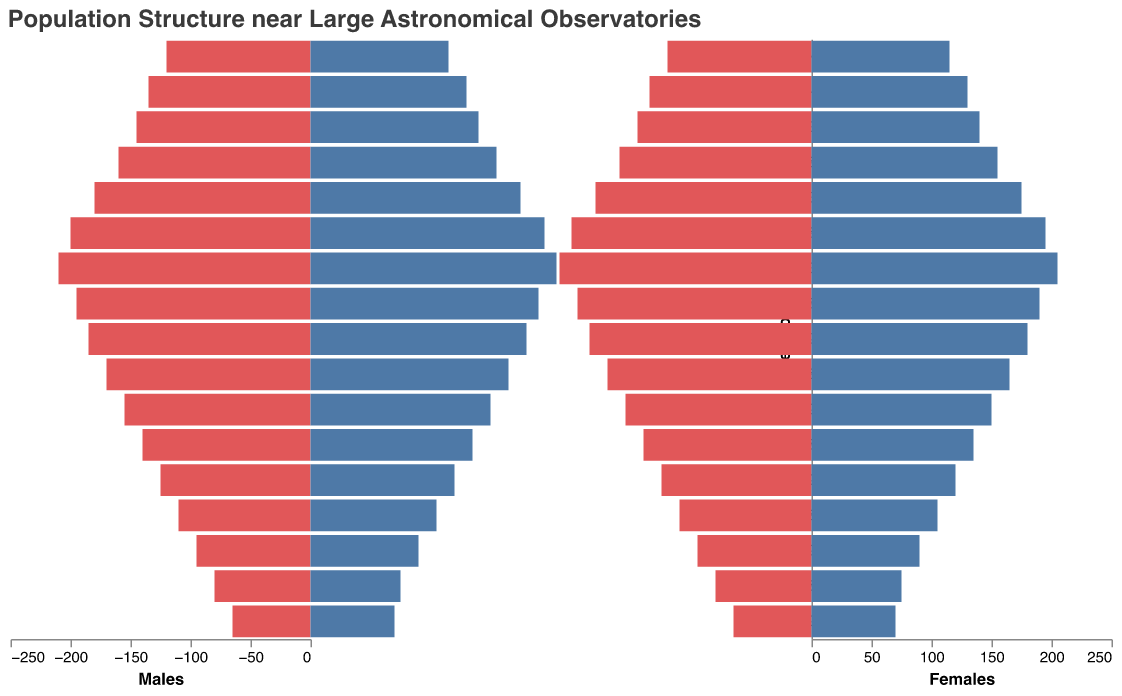What is the title of the figure? The title can be found at the top of the figure. It states what the figure is about.
Answer: Population Structure near Large Astronomical Observatories What is the age group with the highest population for females? Observe the right side of the population pyramid and look for the bar representing the widest segment, which corresponds to females aged 30-34.
Answer: 30-34 How does the population of males aged 25-29 compare to females of the same age group? Compare the lengths of the bars for males and females in the 25-29 age group. The bar for males is slightly longer than for females.
Answer: Males have a higher population What trends can be observed in the population as the age groups increase from 0-4 to 80+ for both genders? Observe the overall shape of the pyramid. Generally, the bars become shorter as the age groups increase, indicating a decreasing population with age.
Answer: Population decreases with age What is the total population for the 70-74 age group? Add the population numbers for males and females in the 70-74 age group: 95 (males) + 90 (females) = 185.
Answer: 185 Which age group has a male population closest to 150? Look for the bar representing males in an age group near the value of 150. The bar for the age group 50-54 is closest with a population of 155.
Answer: 50-54 At what age group is the population of females exactly equal to the population of males? Compare the lengths of bars for both males and females at each age group. The population is equal at the age group 80+, where both genders have very close populations (65 males and 70 females).
Answer: 80+ Which is the age group where the population difference between males and females is the smallest? Calculate the difference in population between males and females for each age group and find the smallest difference. The 0-4 age group has the smallest difference with only 5 individuals.
Answer: 0-4 For which age group is the sum of males and females populations the highest? Add the population numbers for males and females in each age group and compare the sums to find the highest. The age group 30-34 has the highest population sum: 210 (males) + 205 (females) = 415.
Answer: 30-34 How does the population of males aged 15-19 compare to males aged 55-59? Compare the lengths of the bars for males in the 15-19 and 55-59 age groups. The 15-19 age group has a higher population (160) compared to the 55-59 age group (140).
Answer: Males aged 15-19 have a higher population 